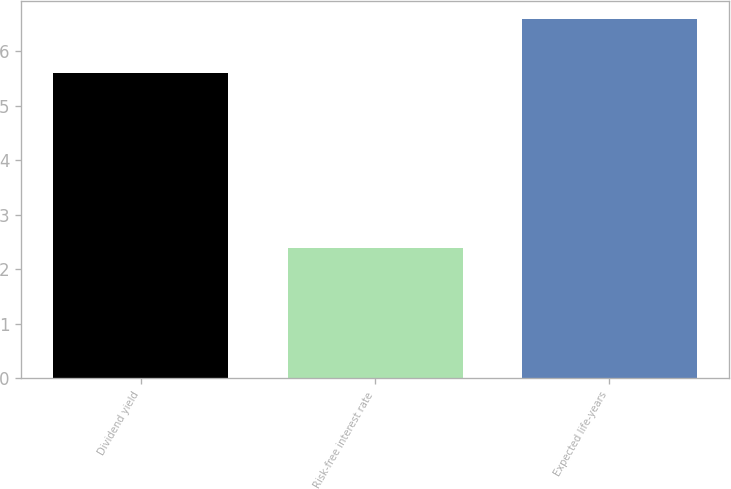Convert chart to OTSL. <chart><loc_0><loc_0><loc_500><loc_500><bar_chart><fcel>Dividend yield<fcel>Risk-free interest rate<fcel>Expected life-years<nl><fcel>5.6<fcel>2.39<fcel>6.6<nl></chart> 